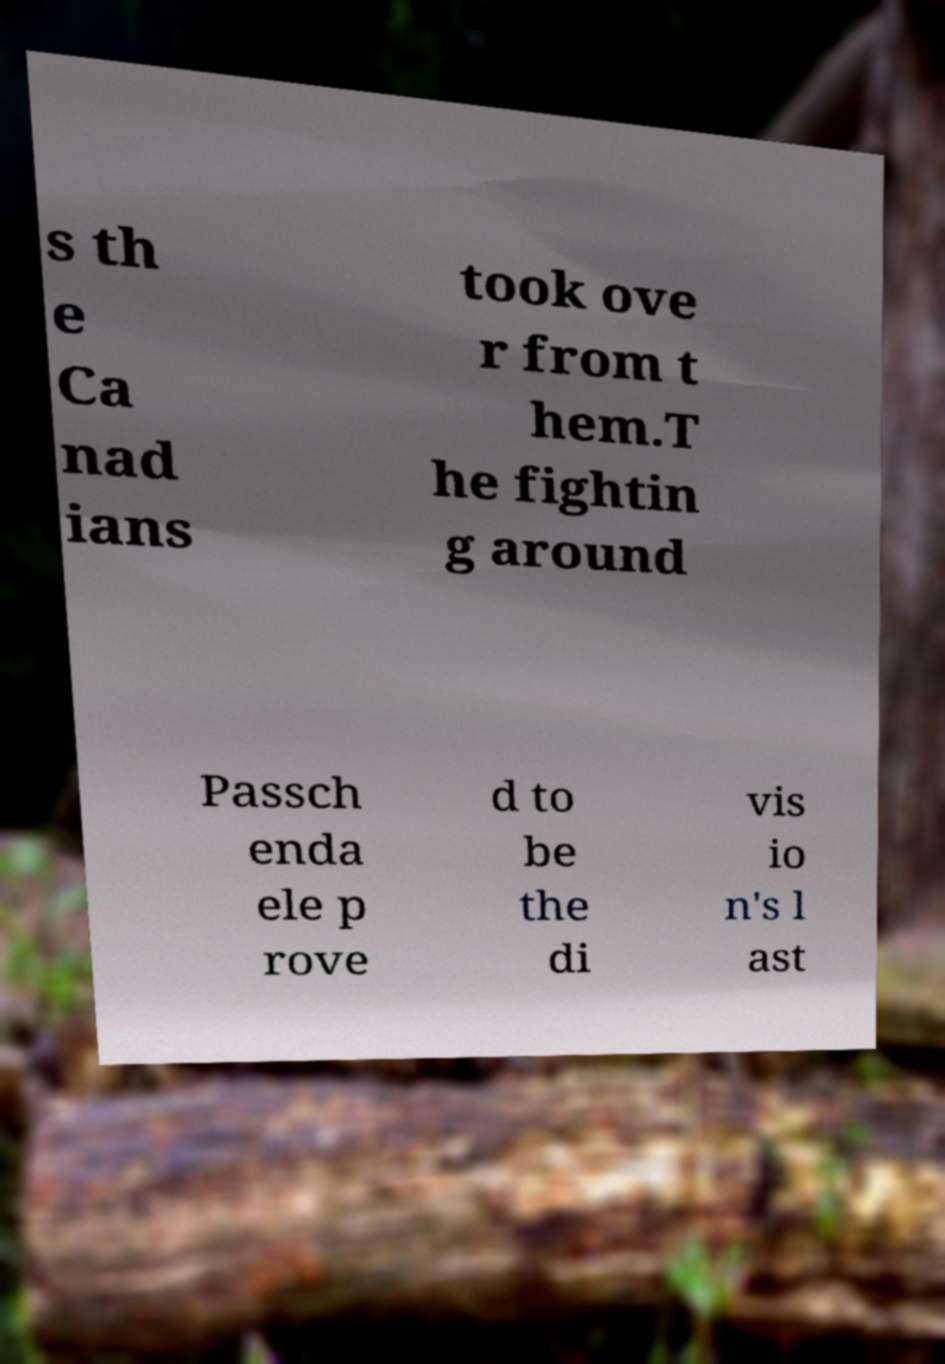Please identify and transcribe the text found in this image. s th e Ca nad ians took ove r from t hem.T he fightin g around Passch enda ele p rove d to be the di vis io n's l ast 